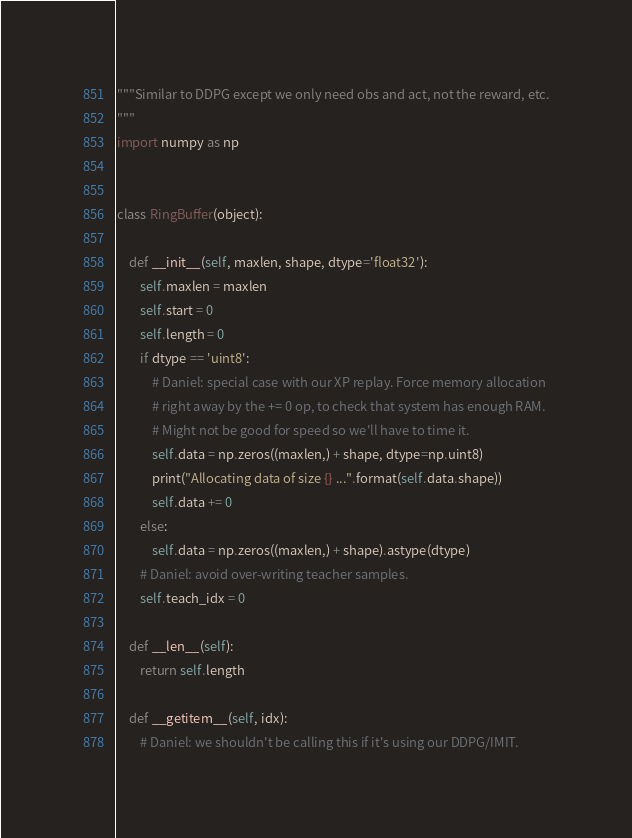<code> <loc_0><loc_0><loc_500><loc_500><_Python_>"""Similar to DDPG except we only need obs and act, not the reward, etc.
"""
import numpy as np


class RingBuffer(object):

    def __init__(self, maxlen, shape, dtype='float32'):
        self.maxlen = maxlen
        self.start = 0
        self.length = 0
        if dtype == 'uint8':
            # Daniel: special case with our XP replay. Force memory allocation
            # right away by the += 0 op, to check that system has enough RAM.
            # Might not be good for speed so we'll have to time it.
            self.data = np.zeros((maxlen,) + shape, dtype=np.uint8)
            print("Allocating data of size {} ...".format(self.data.shape))
            self.data += 0
        else:
            self.data = np.zeros((maxlen,) + shape).astype(dtype)
        # Daniel: avoid over-writing teacher samples.
        self.teach_idx = 0

    def __len__(self):
        return self.length

    def __getitem__(self, idx):
        # Daniel: we shouldn't be calling this if it's using our DDPG/IMIT.</code> 